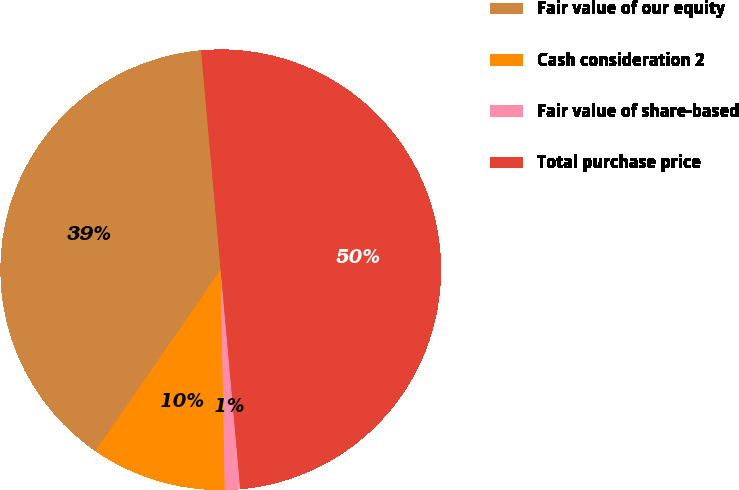Convert chart to OTSL. <chart><loc_0><loc_0><loc_500><loc_500><pie_chart><fcel>Fair value of our equity<fcel>Cash consideration 2<fcel>Fair value of share-based<fcel>Total purchase price<nl><fcel>38.96%<fcel>9.92%<fcel>1.12%<fcel>50.0%<nl></chart> 